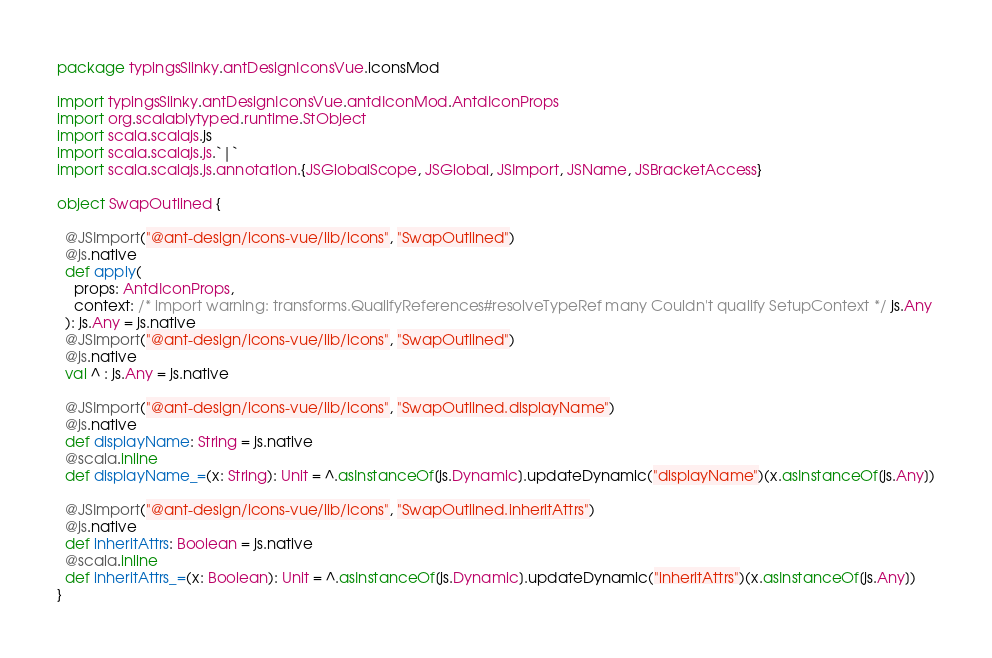Convert code to text. <code><loc_0><loc_0><loc_500><loc_500><_Scala_>package typingsSlinky.antDesignIconsVue.iconsMod

import typingsSlinky.antDesignIconsVue.antdIconMod.AntdIconProps
import org.scalablytyped.runtime.StObject
import scala.scalajs.js
import scala.scalajs.js.`|`
import scala.scalajs.js.annotation.{JSGlobalScope, JSGlobal, JSImport, JSName, JSBracketAccess}

object SwapOutlined {
  
  @JSImport("@ant-design/icons-vue/lib/icons", "SwapOutlined")
  @js.native
  def apply(
    props: AntdIconProps,
    context: /* import warning: transforms.QualifyReferences#resolveTypeRef many Couldn't qualify SetupContext */ js.Any
  ): js.Any = js.native
  @JSImport("@ant-design/icons-vue/lib/icons", "SwapOutlined")
  @js.native
  val ^ : js.Any = js.native
  
  @JSImport("@ant-design/icons-vue/lib/icons", "SwapOutlined.displayName")
  @js.native
  def displayName: String = js.native
  @scala.inline
  def displayName_=(x: String): Unit = ^.asInstanceOf[js.Dynamic].updateDynamic("displayName")(x.asInstanceOf[js.Any])
  
  @JSImport("@ant-design/icons-vue/lib/icons", "SwapOutlined.inheritAttrs")
  @js.native
  def inheritAttrs: Boolean = js.native
  @scala.inline
  def inheritAttrs_=(x: Boolean): Unit = ^.asInstanceOf[js.Dynamic].updateDynamic("inheritAttrs")(x.asInstanceOf[js.Any])
}
</code> 